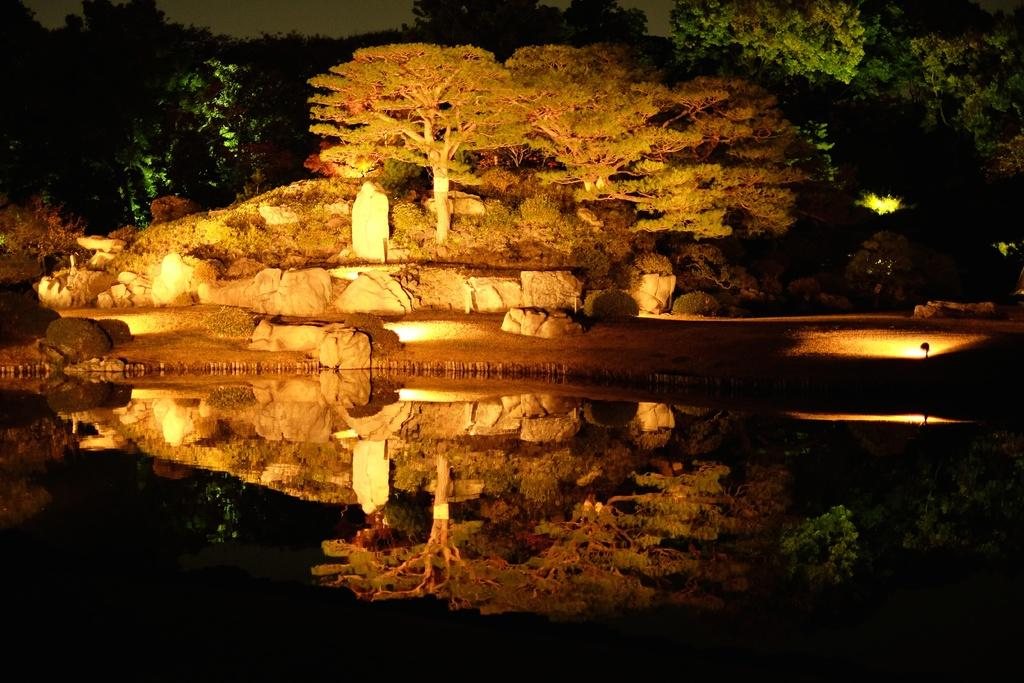What time of day is depicted in the image? The image depicts a night view. What type of terrain can be seen in the image? There are small rocks and trees visible in the image. What natural feature is present in the image? There is a river in the image. What is the source of light in the image? There is visible light in the image. What type of shoe can be seen floating in the river in the image? There is no shoe present in the image; it only depicts a night view with small rocks, trees, and a river. 